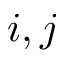<formula> <loc_0><loc_0><loc_500><loc_500>i , j</formula> 